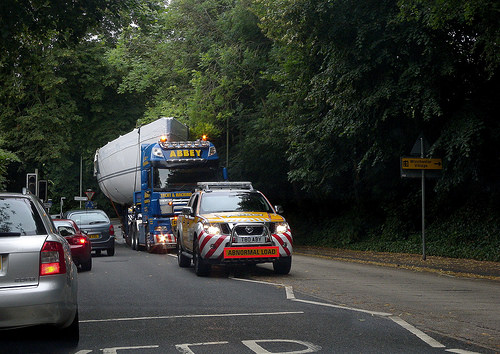<image>
Is the truck in front of the car? No. The truck is not in front of the car. The spatial positioning shows a different relationship between these objects. 